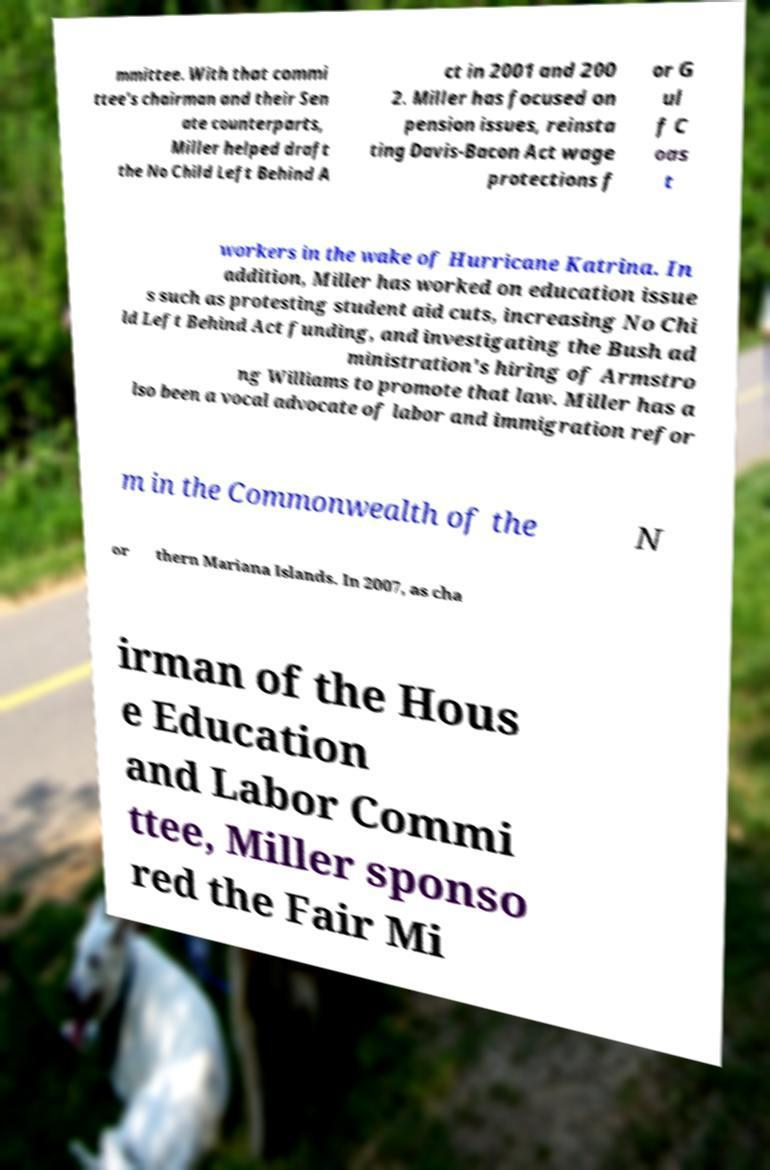Can you accurately transcribe the text from the provided image for me? mmittee. With that commi ttee's chairman and their Sen ate counterparts, Miller helped draft the No Child Left Behind A ct in 2001 and 200 2. Miller has focused on pension issues, reinsta ting Davis-Bacon Act wage protections f or G ul f C oas t workers in the wake of Hurricane Katrina. In addition, Miller has worked on education issue s such as protesting student aid cuts, increasing No Chi ld Left Behind Act funding, and investigating the Bush ad ministration's hiring of Armstro ng Williams to promote that law. Miller has a lso been a vocal advocate of labor and immigration refor m in the Commonwealth of the N or thern Mariana Islands. In 2007, as cha irman of the Hous e Education and Labor Commi ttee, Miller sponso red the Fair Mi 